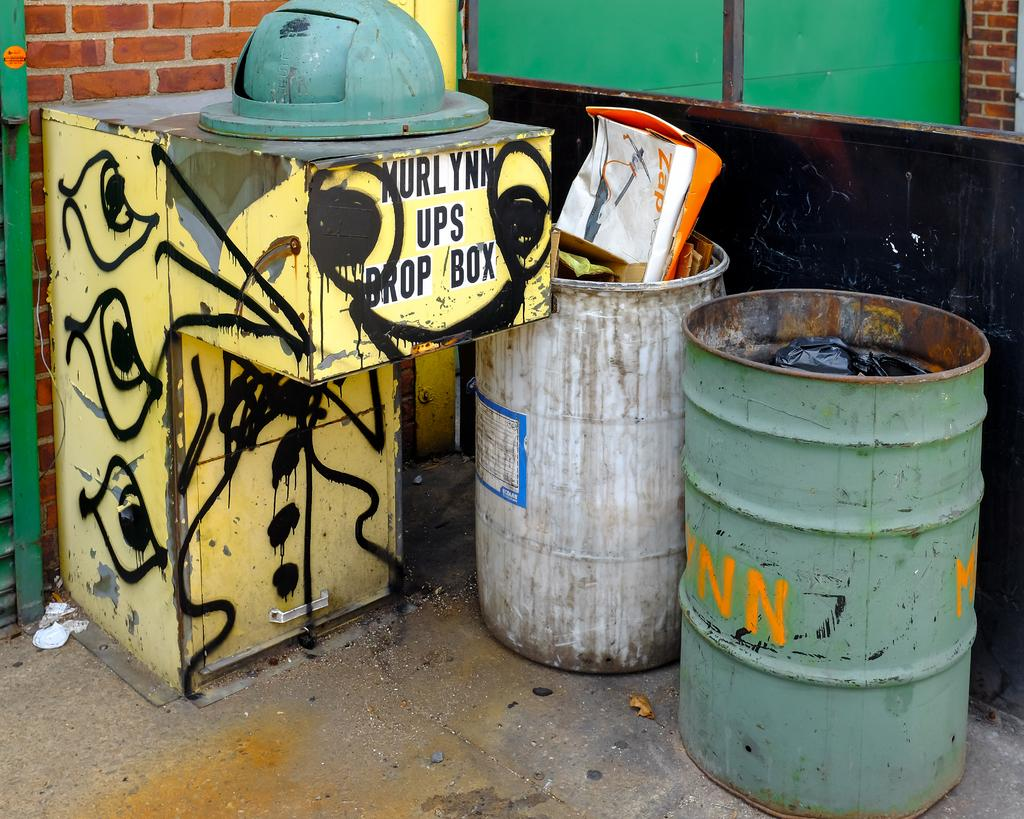<image>
Present a compact description of the photo's key features. The Murlynn UPS drop box is sprayed in graffiti. 